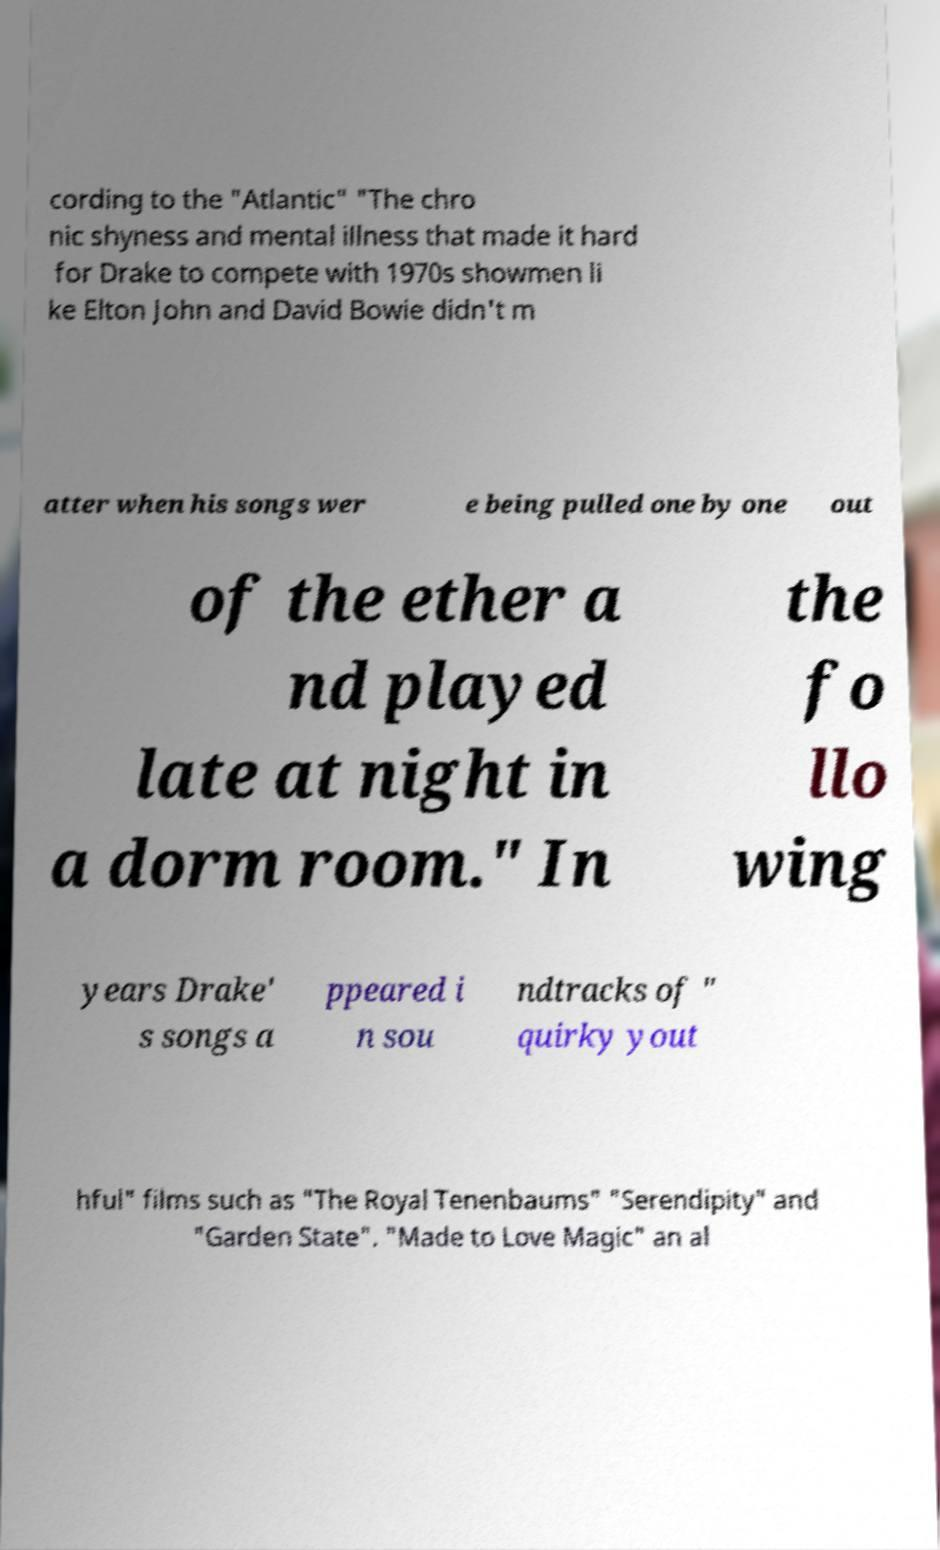What messages or text are displayed in this image? I need them in a readable, typed format. cording to the "Atlantic" "The chro nic shyness and mental illness that made it hard for Drake to compete with 1970s showmen li ke Elton John and David Bowie didn't m atter when his songs wer e being pulled one by one out of the ether a nd played late at night in a dorm room." In the fo llo wing years Drake' s songs a ppeared i n sou ndtracks of " quirky yout hful" films such as "The Royal Tenenbaums" "Serendipity" and "Garden State". "Made to Love Magic" an al 